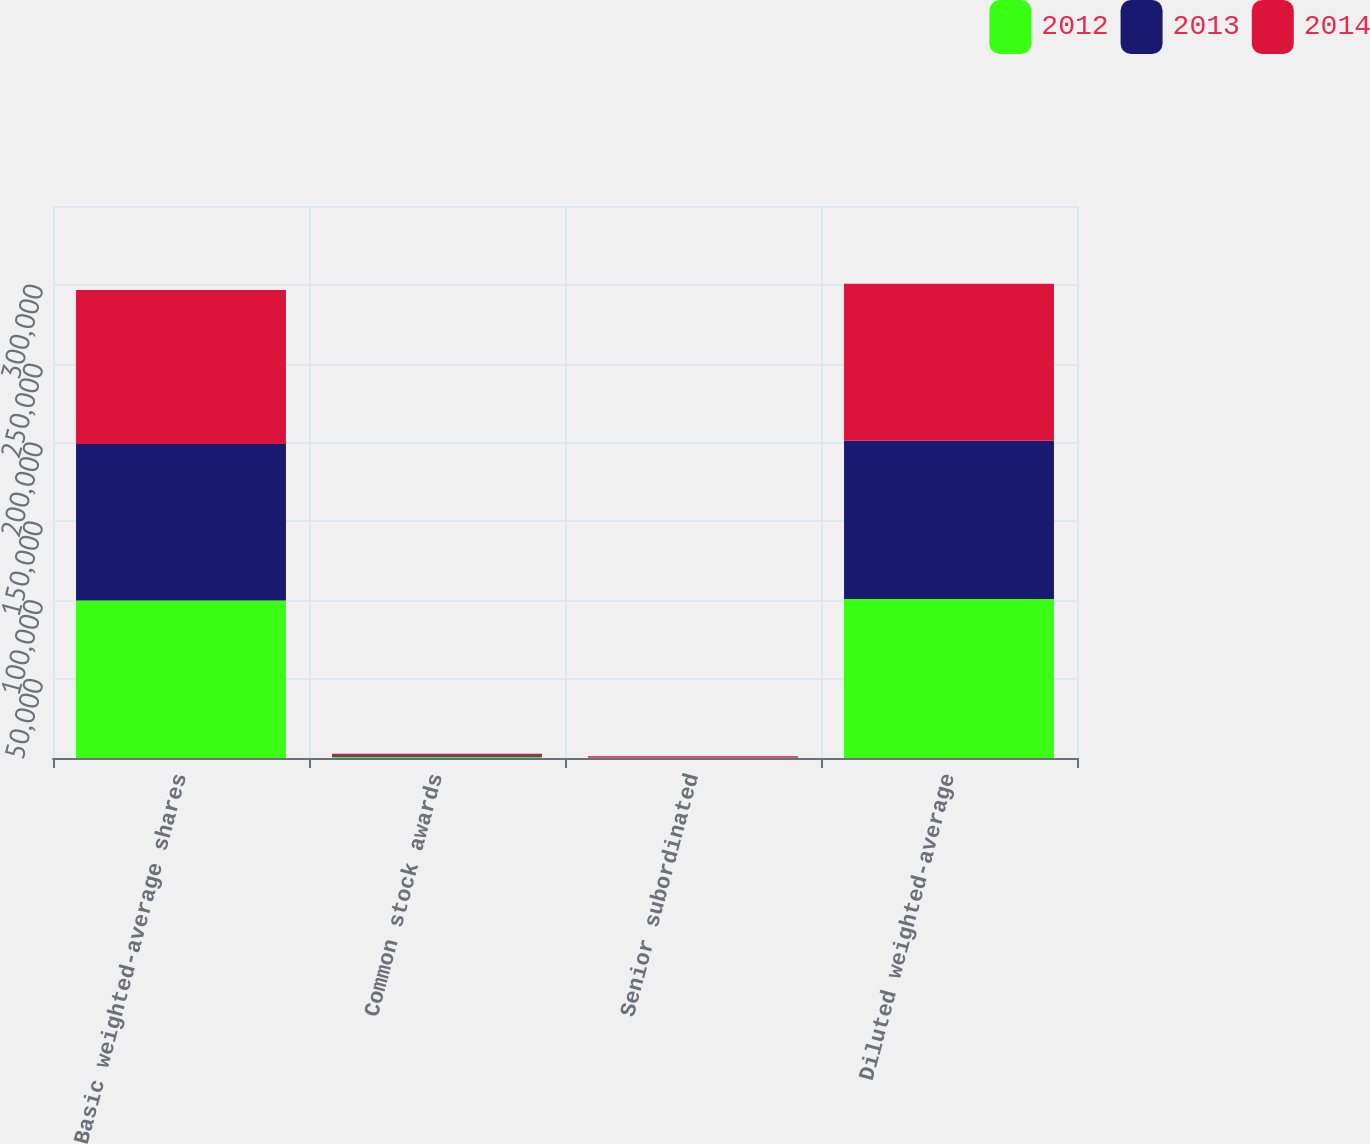Convert chart. <chart><loc_0><loc_0><loc_500><loc_500><stacked_bar_chart><ecel><fcel>Basic weighted-average shares<fcel>Common stock awards<fcel>Senior subordinated<fcel>Diluted weighted-average<nl><fcel>2012<fcel>99916<fcel>816<fcel>152<fcel>100884<nl><fcel>2013<fcel>99123<fcel>891<fcel>195<fcel>100209<nl><fcel>2014<fcel>97702<fcel>1040<fcel>816<fcel>99558<nl></chart> 